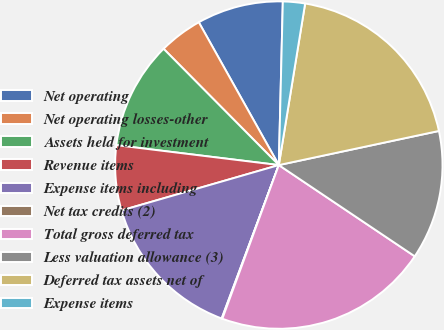Convert chart. <chart><loc_0><loc_0><loc_500><loc_500><pie_chart><fcel>Net operating<fcel>Net operating losses-other<fcel>Assets held for investment<fcel>Revenue items<fcel>Expense items including<fcel>Net tax credits (2)<fcel>Total gross deferred tax<fcel>Less valuation allowance (3)<fcel>Deferred tax assets net of<fcel>Expense items<nl><fcel>8.52%<fcel>4.3%<fcel>10.63%<fcel>6.41%<fcel>14.86%<fcel>0.07%<fcel>21.2%<fcel>12.75%<fcel>19.09%<fcel>2.18%<nl></chart> 